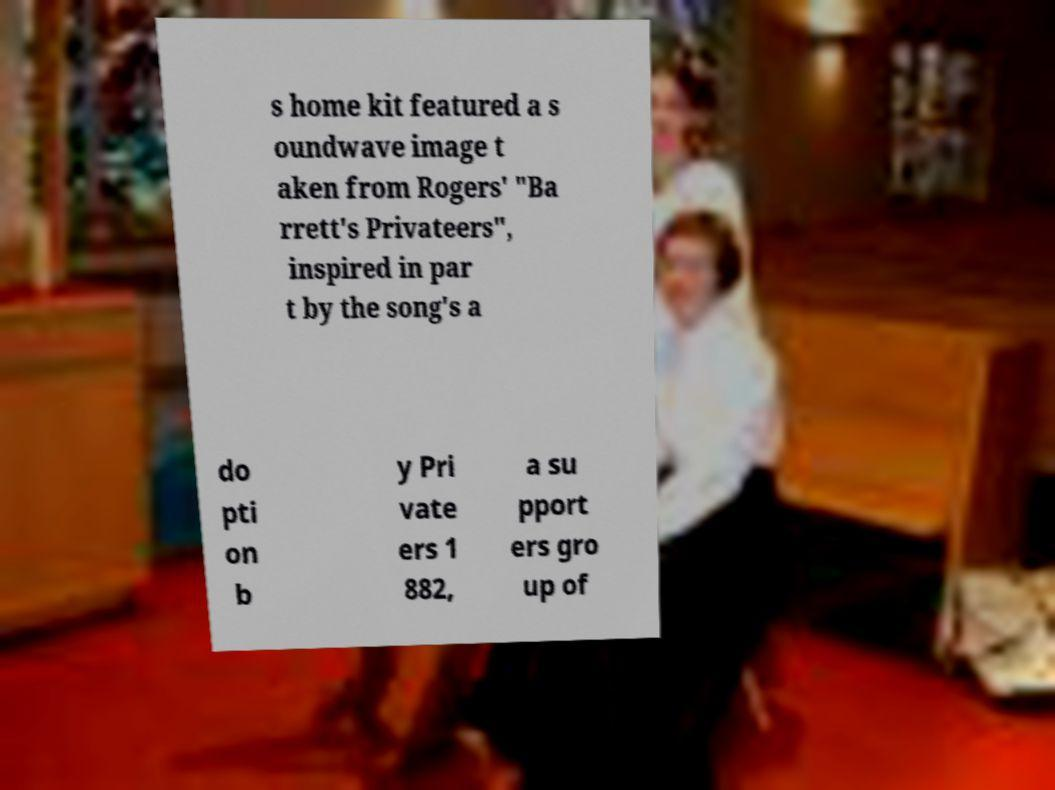Could you extract and type out the text from this image? s home kit featured a s oundwave image t aken from Rogers' "Ba rrett's Privateers", inspired in par t by the song's a do pti on b y Pri vate ers 1 882, a su pport ers gro up of 